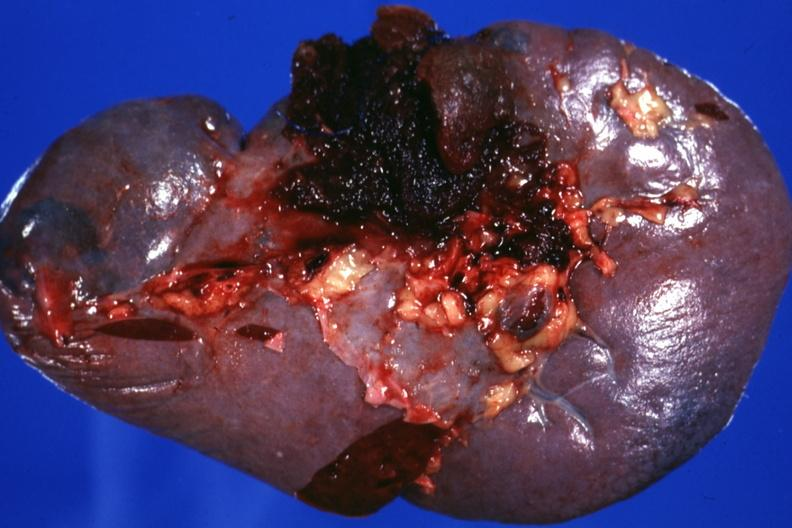what is present?
Answer the question using a single word or phrase. Hematologic 